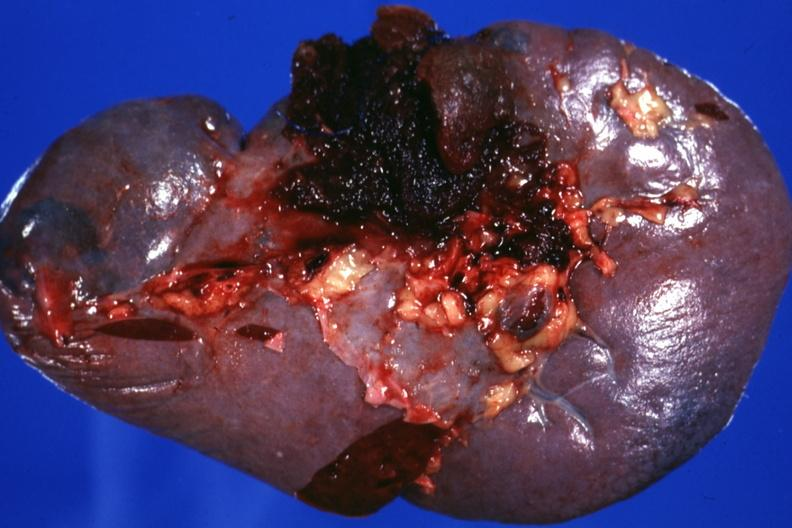what is present?
Answer the question using a single word or phrase. Hematologic 